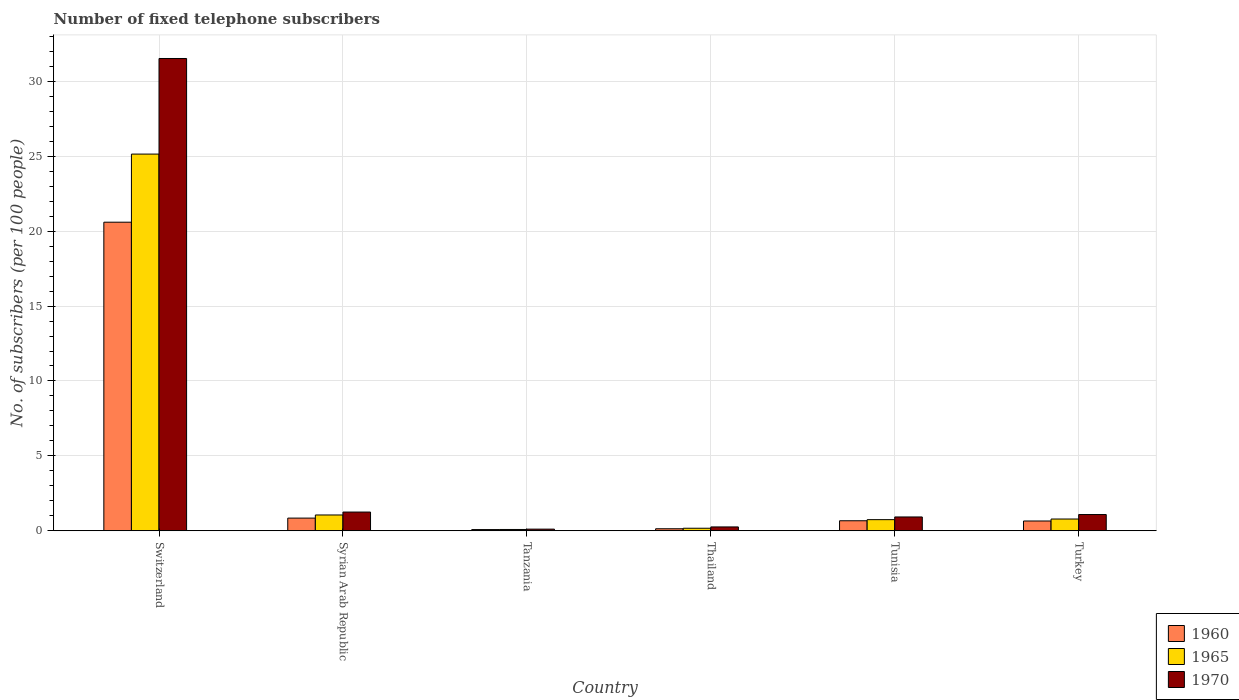How many different coloured bars are there?
Offer a terse response. 3. How many groups of bars are there?
Offer a terse response. 6. What is the label of the 5th group of bars from the left?
Give a very brief answer. Tunisia. What is the number of fixed telephone subscribers in 1970 in Turkey?
Give a very brief answer. 1.08. Across all countries, what is the maximum number of fixed telephone subscribers in 1970?
Give a very brief answer. 31.53. Across all countries, what is the minimum number of fixed telephone subscribers in 1965?
Provide a succinct answer. 0.09. In which country was the number of fixed telephone subscribers in 1965 maximum?
Make the answer very short. Switzerland. In which country was the number of fixed telephone subscribers in 1970 minimum?
Provide a succinct answer. Tanzania. What is the total number of fixed telephone subscribers in 1960 in the graph?
Your response must be concise. 22.99. What is the difference between the number of fixed telephone subscribers in 1960 in Tanzania and that in Turkey?
Your answer should be compact. -0.57. What is the difference between the number of fixed telephone subscribers in 1965 in Tunisia and the number of fixed telephone subscribers in 1960 in Tanzania?
Keep it short and to the point. 0.66. What is the average number of fixed telephone subscribers in 1965 per country?
Your response must be concise. 4.66. What is the difference between the number of fixed telephone subscribers of/in 1960 and number of fixed telephone subscribers of/in 1965 in Tanzania?
Give a very brief answer. -0.01. In how many countries, is the number of fixed telephone subscribers in 1965 greater than 25?
Provide a short and direct response. 1. What is the ratio of the number of fixed telephone subscribers in 1970 in Syrian Arab Republic to that in Tanzania?
Ensure brevity in your answer.  11.36. Is the difference between the number of fixed telephone subscribers in 1960 in Syrian Arab Republic and Tunisia greater than the difference between the number of fixed telephone subscribers in 1965 in Syrian Arab Republic and Tunisia?
Provide a short and direct response. No. What is the difference between the highest and the second highest number of fixed telephone subscribers in 1965?
Offer a terse response. -24.36. What is the difference between the highest and the lowest number of fixed telephone subscribers in 1965?
Provide a succinct answer. 25.06. What does the 2nd bar from the left in Tunisia represents?
Your answer should be compact. 1965. What does the 2nd bar from the right in Tunisia represents?
Give a very brief answer. 1965. Are all the bars in the graph horizontal?
Your response must be concise. No. What is the difference between two consecutive major ticks on the Y-axis?
Offer a terse response. 5. Are the values on the major ticks of Y-axis written in scientific E-notation?
Your answer should be very brief. No. Where does the legend appear in the graph?
Ensure brevity in your answer.  Bottom right. How many legend labels are there?
Give a very brief answer. 3. How are the legend labels stacked?
Give a very brief answer. Vertical. What is the title of the graph?
Give a very brief answer. Number of fixed telephone subscribers. Does "2002" appear as one of the legend labels in the graph?
Your answer should be compact. No. What is the label or title of the X-axis?
Ensure brevity in your answer.  Country. What is the label or title of the Y-axis?
Your answer should be compact. No. of subscribers (per 100 people). What is the No. of subscribers (per 100 people) in 1960 in Switzerland?
Give a very brief answer. 20.6. What is the No. of subscribers (per 100 people) of 1965 in Switzerland?
Your answer should be compact. 25.15. What is the No. of subscribers (per 100 people) of 1970 in Switzerland?
Provide a short and direct response. 31.53. What is the No. of subscribers (per 100 people) in 1960 in Syrian Arab Republic?
Your answer should be very brief. 0.85. What is the No. of subscribers (per 100 people) of 1965 in Syrian Arab Republic?
Offer a very short reply. 1.06. What is the No. of subscribers (per 100 people) of 1970 in Syrian Arab Republic?
Your answer should be very brief. 1.25. What is the No. of subscribers (per 100 people) of 1960 in Tanzania?
Your answer should be very brief. 0.08. What is the No. of subscribers (per 100 people) of 1965 in Tanzania?
Ensure brevity in your answer.  0.09. What is the No. of subscribers (per 100 people) in 1970 in Tanzania?
Provide a short and direct response. 0.11. What is the No. of subscribers (per 100 people) of 1960 in Thailand?
Provide a succinct answer. 0.14. What is the No. of subscribers (per 100 people) of 1965 in Thailand?
Provide a succinct answer. 0.17. What is the No. of subscribers (per 100 people) of 1970 in Thailand?
Ensure brevity in your answer.  0.26. What is the No. of subscribers (per 100 people) in 1960 in Tunisia?
Your answer should be very brief. 0.67. What is the No. of subscribers (per 100 people) of 1965 in Tunisia?
Keep it short and to the point. 0.74. What is the No. of subscribers (per 100 people) of 1970 in Tunisia?
Keep it short and to the point. 0.92. What is the No. of subscribers (per 100 people) in 1960 in Turkey?
Provide a succinct answer. 0.65. What is the No. of subscribers (per 100 people) in 1965 in Turkey?
Offer a very short reply. 0.79. What is the No. of subscribers (per 100 people) in 1970 in Turkey?
Your answer should be compact. 1.08. Across all countries, what is the maximum No. of subscribers (per 100 people) of 1960?
Provide a succinct answer. 20.6. Across all countries, what is the maximum No. of subscribers (per 100 people) in 1965?
Give a very brief answer. 25.15. Across all countries, what is the maximum No. of subscribers (per 100 people) of 1970?
Keep it short and to the point. 31.53. Across all countries, what is the minimum No. of subscribers (per 100 people) in 1960?
Make the answer very short. 0.08. Across all countries, what is the minimum No. of subscribers (per 100 people) in 1965?
Your answer should be compact. 0.09. Across all countries, what is the minimum No. of subscribers (per 100 people) of 1970?
Ensure brevity in your answer.  0.11. What is the total No. of subscribers (per 100 people) of 1960 in the graph?
Offer a very short reply. 22.99. What is the total No. of subscribers (per 100 people) of 1965 in the graph?
Ensure brevity in your answer.  27.99. What is the total No. of subscribers (per 100 people) of 1970 in the graph?
Your answer should be compact. 35.15. What is the difference between the No. of subscribers (per 100 people) in 1960 in Switzerland and that in Syrian Arab Republic?
Make the answer very short. 19.75. What is the difference between the No. of subscribers (per 100 people) in 1965 in Switzerland and that in Syrian Arab Republic?
Your response must be concise. 24.09. What is the difference between the No. of subscribers (per 100 people) of 1970 in Switzerland and that in Syrian Arab Republic?
Provide a succinct answer. 30.28. What is the difference between the No. of subscribers (per 100 people) in 1960 in Switzerland and that in Tanzania?
Ensure brevity in your answer.  20.52. What is the difference between the No. of subscribers (per 100 people) in 1965 in Switzerland and that in Tanzania?
Offer a terse response. 25.06. What is the difference between the No. of subscribers (per 100 people) of 1970 in Switzerland and that in Tanzania?
Your response must be concise. 31.42. What is the difference between the No. of subscribers (per 100 people) of 1960 in Switzerland and that in Thailand?
Keep it short and to the point. 20.46. What is the difference between the No. of subscribers (per 100 people) in 1965 in Switzerland and that in Thailand?
Make the answer very short. 24.98. What is the difference between the No. of subscribers (per 100 people) of 1970 in Switzerland and that in Thailand?
Make the answer very short. 31.27. What is the difference between the No. of subscribers (per 100 people) of 1960 in Switzerland and that in Tunisia?
Keep it short and to the point. 19.93. What is the difference between the No. of subscribers (per 100 people) in 1965 in Switzerland and that in Tunisia?
Keep it short and to the point. 24.4. What is the difference between the No. of subscribers (per 100 people) of 1970 in Switzerland and that in Tunisia?
Offer a very short reply. 30.6. What is the difference between the No. of subscribers (per 100 people) in 1960 in Switzerland and that in Turkey?
Ensure brevity in your answer.  19.95. What is the difference between the No. of subscribers (per 100 people) of 1965 in Switzerland and that in Turkey?
Ensure brevity in your answer.  24.36. What is the difference between the No. of subscribers (per 100 people) in 1970 in Switzerland and that in Turkey?
Your response must be concise. 30.44. What is the difference between the No. of subscribers (per 100 people) of 1960 in Syrian Arab Republic and that in Tanzania?
Provide a short and direct response. 0.77. What is the difference between the No. of subscribers (per 100 people) of 1965 in Syrian Arab Republic and that in Tanzania?
Provide a succinct answer. 0.97. What is the difference between the No. of subscribers (per 100 people) of 1970 in Syrian Arab Republic and that in Tanzania?
Make the answer very short. 1.14. What is the difference between the No. of subscribers (per 100 people) in 1960 in Syrian Arab Republic and that in Thailand?
Offer a terse response. 0.71. What is the difference between the No. of subscribers (per 100 people) of 1965 in Syrian Arab Republic and that in Thailand?
Your answer should be compact. 0.89. What is the difference between the No. of subscribers (per 100 people) in 1960 in Syrian Arab Republic and that in Tunisia?
Provide a short and direct response. 0.18. What is the difference between the No. of subscribers (per 100 people) in 1965 in Syrian Arab Republic and that in Tunisia?
Provide a short and direct response. 0.31. What is the difference between the No. of subscribers (per 100 people) of 1970 in Syrian Arab Republic and that in Tunisia?
Your answer should be compact. 0.33. What is the difference between the No. of subscribers (per 100 people) in 1960 in Syrian Arab Republic and that in Turkey?
Provide a succinct answer. 0.19. What is the difference between the No. of subscribers (per 100 people) of 1965 in Syrian Arab Republic and that in Turkey?
Your answer should be compact. 0.27. What is the difference between the No. of subscribers (per 100 people) in 1960 in Tanzania and that in Thailand?
Offer a very short reply. -0.06. What is the difference between the No. of subscribers (per 100 people) of 1965 in Tanzania and that in Thailand?
Provide a short and direct response. -0.08. What is the difference between the No. of subscribers (per 100 people) in 1970 in Tanzania and that in Thailand?
Provide a succinct answer. -0.15. What is the difference between the No. of subscribers (per 100 people) of 1960 in Tanzania and that in Tunisia?
Your answer should be compact. -0.59. What is the difference between the No. of subscribers (per 100 people) of 1965 in Tanzania and that in Tunisia?
Keep it short and to the point. -0.66. What is the difference between the No. of subscribers (per 100 people) of 1970 in Tanzania and that in Tunisia?
Your answer should be very brief. -0.81. What is the difference between the No. of subscribers (per 100 people) in 1960 in Tanzania and that in Turkey?
Make the answer very short. -0.57. What is the difference between the No. of subscribers (per 100 people) of 1965 in Tanzania and that in Turkey?
Keep it short and to the point. -0.7. What is the difference between the No. of subscribers (per 100 people) of 1970 in Tanzania and that in Turkey?
Your answer should be compact. -0.97. What is the difference between the No. of subscribers (per 100 people) of 1960 in Thailand and that in Tunisia?
Your response must be concise. -0.53. What is the difference between the No. of subscribers (per 100 people) in 1965 in Thailand and that in Tunisia?
Give a very brief answer. -0.57. What is the difference between the No. of subscribers (per 100 people) of 1970 in Thailand and that in Tunisia?
Your answer should be compact. -0.67. What is the difference between the No. of subscribers (per 100 people) in 1960 in Thailand and that in Turkey?
Offer a terse response. -0.52. What is the difference between the No. of subscribers (per 100 people) in 1965 in Thailand and that in Turkey?
Your response must be concise. -0.62. What is the difference between the No. of subscribers (per 100 people) of 1970 in Thailand and that in Turkey?
Keep it short and to the point. -0.83. What is the difference between the No. of subscribers (per 100 people) of 1960 in Tunisia and that in Turkey?
Ensure brevity in your answer.  0.02. What is the difference between the No. of subscribers (per 100 people) of 1965 in Tunisia and that in Turkey?
Offer a terse response. -0.04. What is the difference between the No. of subscribers (per 100 people) of 1970 in Tunisia and that in Turkey?
Offer a very short reply. -0.16. What is the difference between the No. of subscribers (per 100 people) of 1960 in Switzerland and the No. of subscribers (per 100 people) of 1965 in Syrian Arab Republic?
Provide a succinct answer. 19.54. What is the difference between the No. of subscribers (per 100 people) of 1960 in Switzerland and the No. of subscribers (per 100 people) of 1970 in Syrian Arab Republic?
Ensure brevity in your answer.  19.35. What is the difference between the No. of subscribers (per 100 people) of 1965 in Switzerland and the No. of subscribers (per 100 people) of 1970 in Syrian Arab Republic?
Provide a succinct answer. 23.9. What is the difference between the No. of subscribers (per 100 people) of 1960 in Switzerland and the No. of subscribers (per 100 people) of 1965 in Tanzania?
Provide a succinct answer. 20.51. What is the difference between the No. of subscribers (per 100 people) of 1960 in Switzerland and the No. of subscribers (per 100 people) of 1970 in Tanzania?
Provide a short and direct response. 20.49. What is the difference between the No. of subscribers (per 100 people) of 1965 in Switzerland and the No. of subscribers (per 100 people) of 1970 in Tanzania?
Offer a terse response. 25.04. What is the difference between the No. of subscribers (per 100 people) of 1960 in Switzerland and the No. of subscribers (per 100 people) of 1965 in Thailand?
Your answer should be very brief. 20.43. What is the difference between the No. of subscribers (per 100 people) in 1960 in Switzerland and the No. of subscribers (per 100 people) in 1970 in Thailand?
Offer a terse response. 20.34. What is the difference between the No. of subscribers (per 100 people) in 1965 in Switzerland and the No. of subscribers (per 100 people) in 1970 in Thailand?
Your answer should be very brief. 24.89. What is the difference between the No. of subscribers (per 100 people) in 1960 in Switzerland and the No. of subscribers (per 100 people) in 1965 in Tunisia?
Ensure brevity in your answer.  19.86. What is the difference between the No. of subscribers (per 100 people) of 1960 in Switzerland and the No. of subscribers (per 100 people) of 1970 in Tunisia?
Your answer should be compact. 19.68. What is the difference between the No. of subscribers (per 100 people) of 1965 in Switzerland and the No. of subscribers (per 100 people) of 1970 in Tunisia?
Provide a short and direct response. 24.22. What is the difference between the No. of subscribers (per 100 people) of 1960 in Switzerland and the No. of subscribers (per 100 people) of 1965 in Turkey?
Offer a terse response. 19.81. What is the difference between the No. of subscribers (per 100 people) of 1960 in Switzerland and the No. of subscribers (per 100 people) of 1970 in Turkey?
Your response must be concise. 19.52. What is the difference between the No. of subscribers (per 100 people) in 1965 in Switzerland and the No. of subscribers (per 100 people) in 1970 in Turkey?
Offer a very short reply. 24.06. What is the difference between the No. of subscribers (per 100 people) of 1960 in Syrian Arab Republic and the No. of subscribers (per 100 people) of 1965 in Tanzania?
Offer a terse response. 0.76. What is the difference between the No. of subscribers (per 100 people) of 1960 in Syrian Arab Republic and the No. of subscribers (per 100 people) of 1970 in Tanzania?
Keep it short and to the point. 0.74. What is the difference between the No. of subscribers (per 100 people) of 1965 in Syrian Arab Republic and the No. of subscribers (per 100 people) of 1970 in Tanzania?
Your response must be concise. 0.95. What is the difference between the No. of subscribers (per 100 people) of 1960 in Syrian Arab Republic and the No. of subscribers (per 100 people) of 1965 in Thailand?
Provide a short and direct response. 0.68. What is the difference between the No. of subscribers (per 100 people) in 1960 in Syrian Arab Republic and the No. of subscribers (per 100 people) in 1970 in Thailand?
Give a very brief answer. 0.59. What is the difference between the No. of subscribers (per 100 people) in 1965 in Syrian Arab Republic and the No. of subscribers (per 100 people) in 1970 in Thailand?
Keep it short and to the point. 0.8. What is the difference between the No. of subscribers (per 100 people) of 1960 in Syrian Arab Republic and the No. of subscribers (per 100 people) of 1965 in Tunisia?
Offer a terse response. 0.1. What is the difference between the No. of subscribers (per 100 people) of 1960 in Syrian Arab Republic and the No. of subscribers (per 100 people) of 1970 in Tunisia?
Your answer should be very brief. -0.08. What is the difference between the No. of subscribers (per 100 people) in 1965 in Syrian Arab Republic and the No. of subscribers (per 100 people) in 1970 in Tunisia?
Your answer should be very brief. 0.13. What is the difference between the No. of subscribers (per 100 people) of 1960 in Syrian Arab Republic and the No. of subscribers (per 100 people) of 1965 in Turkey?
Offer a terse response. 0.06. What is the difference between the No. of subscribers (per 100 people) in 1960 in Syrian Arab Republic and the No. of subscribers (per 100 people) in 1970 in Turkey?
Give a very brief answer. -0.24. What is the difference between the No. of subscribers (per 100 people) in 1965 in Syrian Arab Republic and the No. of subscribers (per 100 people) in 1970 in Turkey?
Provide a succinct answer. -0.03. What is the difference between the No. of subscribers (per 100 people) in 1960 in Tanzania and the No. of subscribers (per 100 people) in 1965 in Thailand?
Make the answer very short. -0.09. What is the difference between the No. of subscribers (per 100 people) of 1960 in Tanzania and the No. of subscribers (per 100 people) of 1970 in Thailand?
Make the answer very short. -0.18. What is the difference between the No. of subscribers (per 100 people) in 1965 in Tanzania and the No. of subscribers (per 100 people) in 1970 in Thailand?
Your answer should be compact. -0.17. What is the difference between the No. of subscribers (per 100 people) in 1960 in Tanzania and the No. of subscribers (per 100 people) in 1965 in Tunisia?
Offer a terse response. -0.66. What is the difference between the No. of subscribers (per 100 people) of 1960 in Tanzania and the No. of subscribers (per 100 people) of 1970 in Tunisia?
Your answer should be very brief. -0.84. What is the difference between the No. of subscribers (per 100 people) in 1965 in Tanzania and the No. of subscribers (per 100 people) in 1970 in Tunisia?
Provide a short and direct response. -0.84. What is the difference between the No. of subscribers (per 100 people) in 1960 in Tanzania and the No. of subscribers (per 100 people) in 1965 in Turkey?
Ensure brevity in your answer.  -0.7. What is the difference between the No. of subscribers (per 100 people) in 1960 in Tanzania and the No. of subscribers (per 100 people) in 1970 in Turkey?
Your response must be concise. -1. What is the difference between the No. of subscribers (per 100 people) of 1965 in Tanzania and the No. of subscribers (per 100 people) of 1970 in Turkey?
Make the answer very short. -1. What is the difference between the No. of subscribers (per 100 people) of 1960 in Thailand and the No. of subscribers (per 100 people) of 1965 in Tunisia?
Offer a very short reply. -0.61. What is the difference between the No. of subscribers (per 100 people) of 1960 in Thailand and the No. of subscribers (per 100 people) of 1970 in Tunisia?
Give a very brief answer. -0.79. What is the difference between the No. of subscribers (per 100 people) of 1965 in Thailand and the No. of subscribers (per 100 people) of 1970 in Tunisia?
Offer a very short reply. -0.75. What is the difference between the No. of subscribers (per 100 people) of 1960 in Thailand and the No. of subscribers (per 100 people) of 1965 in Turkey?
Provide a short and direct response. -0.65. What is the difference between the No. of subscribers (per 100 people) of 1960 in Thailand and the No. of subscribers (per 100 people) of 1970 in Turkey?
Make the answer very short. -0.95. What is the difference between the No. of subscribers (per 100 people) in 1965 in Thailand and the No. of subscribers (per 100 people) in 1970 in Turkey?
Your answer should be compact. -0.91. What is the difference between the No. of subscribers (per 100 people) in 1960 in Tunisia and the No. of subscribers (per 100 people) in 1965 in Turkey?
Keep it short and to the point. -0.12. What is the difference between the No. of subscribers (per 100 people) of 1960 in Tunisia and the No. of subscribers (per 100 people) of 1970 in Turkey?
Make the answer very short. -0.41. What is the difference between the No. of subscribers (per 100 people) of 1965 in Tunisia and the No. of subscribers (per 100 people) of 1970 in Turkey?
Your answer should be compact. -0.34. What is the average No. of subscribers (per 100 people) in 1960 per country?
Give a very brief answer. 3.83. What is the average No. of subscribers (per 100 people) of 1965 per country?
Provide a short and direct response. 4.66. What is the average No. of subscribers (per 100 people) of 1970 per country?
Ensure brevity in your answer.  5.86. What is the difference between the No. of subscribers (per 100 people) in 1960 and No. of subscribers (per 100 people) in 1965 in Switzerland?
Your response must be concise. -4.55. What is the difference between the No. of subscribers (per 100 people) of 1960 and No. of subscribers (per 100 people) of 1970 in Switzerland?
Your response must be concise. -10.93. What is the difference between the No. of subscribers (per 100 people) of 1965 and No. of subscribers (per 100 people) of 1970 in Switzerland?
Offer a terse response. -6.38. What is the difference between the No. of subscribers (per 100 people) of 1960 and No. of subscribers (per 100 people) of 1965 in Syrian Arab Republic?
Provide a short and direct response. -0.21. What is the difference between the No. of subscribers (per 100 people) in 1960 and No. of subscribers (per 100 people) in 1970 in Syrian Arab Republic?
Provide a short and direct response. -0.4. What is the difference between the No. of subscribers (per 100 people) in 1965 and No. of subscribers (per 100 people) in 1970 in Syrian Arab Republic?
Your answer should be compact. -0.2. What is the difference between the No. of subscribers (per 100 people) in 1960 and No. of subscribers (per 100 people) in 1965 in Tanzania?
Give a very brief answer. -0.01. What is the difference between the No. of subscribers (per 100 people) in 1960 and No. of subscribers (per 100 people) in 1970 in Tanzania?
Offer a very short reply. -0.03. What is the difference between the No. of subscribers (per 100 people) of 1965 and No. of subscribers (per 100 people) of 1970 in Tanzania?
Offer a terse response. -0.02. What is the difference between the No. of subscribers (per 100 people) of 1960 and No. of subscribers (per 100 people) of 1965 in Thailand?
Make the answer very short. -0.03. What is the difference between the No. of subscribers (per 100 people) in 1960 and No. of subscribers (per 100 people) in 1970 in Thailand?
Offer a very short reply. -0.12. What is the difference between the No. of subscribers (per 100 people) in 1965 and No. of subscribers (per 100 people) in 1970 in Thailand?
Provide a succinct answer. -0.09. What is the difference between the No. of subscribers (per 100 people) of 1960 and No. of subscribers (per 100 people) of 1965 in Tunisia?
Ensure brevity in your answer.  -0.07. What is the difference between the No. of subscribers (per 100 people) in 1960 and No. of subscribers (per 100 people) in 1970 in Tunisia?
Offer a terse response. -0.25. What is the difference between the No. of subscribers (per 100 people) of 1965 and No. of subscribers (per 100 people) of 1970 in Tunisia?
Your answer should be very brief. -0.18. What is the difference between the No. of subscribers (per 100 people) of 1960 and No. of subscribers (per 100 people) of 1965 in Turkey?
Provide a short and direct response. -0.13. What is the difference between the No. of subscribers (per 100 people) in 1960 and No. of subscribers (per 100 people) in 1970 in Turkey?
Your response must be concise. -0.43. What is the difference between the No. of subscribers (per 100 people) of 1965 and No. of subscribers (per 100 people) of 1970 in Turkey?
Offer a terse response. -0.3. What is the ratio of the No. of subscribers (per 100 people) in 1960 in Switzerland to that in Syrian Arab Republic?
Provide a short and direct response. 24.33. What is the ratio of the No. of subscribers (per 100 people) in 1965 in Switzerland to that in Syrian Arab Republic?
Your response must be concise. 23.82. What is the ratio of the No. of subscribers (per 100 people) in 1970 in Switzerland to that in Syrian Arab Republic?
Your response must be concise. 25.2. What is the ratio of the No. of subscribers (per 100 people) of 1960 in Switzerland to that in Tanzania?
Ensure brevity in your answer.  255.26. What is the ratio of the No. of subscribers (per 100 people) in 1965 in Switzerland to that in Tanzania?
Provide a short and direct response. 287.14. What is the ratio of the No. of subscribers (per 100 people) of 1970 in Switzerland to that in Tanzania?
Ensure brevity in your answer.  286.38. What is the ratio of the No. of subscribers (per 100 people) of 1960 in Switzerland to that in Thailand?
Offer a terse response. 151.73. What is the ratio of the No. of subscribers (per 100 people) of 1965 in Switzerland to that in Thailand?
Ensure brevity in your answer.  148.16. What is the ratio of the No. of subscribers (per 100 people) in 1970 in Switzerland to that in Thailand?
Offer a terse response. 122.39. What is the ratio of the No. of subscribers (per 100 people) of 1960 in Switzerland to that in Tunisia?
Keep it short and to the point. 30.76. What is the ratio of the No. of subscribers (per 100 people) in 1965 in Switzerland to that in Tunisia?
Offer a terse response. 33.82. What is the ratio of the No. of subscribers (per 100 people) in 1970 in Switzerland to that in Tunisia?
Your answer should be compact. 34.15. What is the ratio of the No. of subscribers (per 100 people) of 1960 in Switzerland to that in Turkey?
Offer a terse response. 31.53. What is the ratio of the No. of subscribers (per 100 people) in 1965 in Switzerland to that in Turkey?
Your response must be concise. 32.03. What is the ratio of the No. of subscribers (per 100 people) in 1970 in Switzerland to that in Turkey?
Give a very brief answer. 29.08. What is the ratio of the No. of subscribers (per 100 people) in 1960 in Syrian Arab Republic to that in Tanzania?
Give a very brief answer. 10.49. What is the ratio of the No. of subscribers (per 100 people) in 1965 in Syrian Arab Republic to that in Tanzania?
Your answer should be compact. 12.06. What is the ratio of the No. of subscribers (per 100 people) of 1970 in Syrian Arab Republic to that in Tanzania?
Your answer should be very brief. 11.36. What is the ratio of the No. of subscribers (per 100 people) of 1960 in Syrian Arab Republic to that in Thailand?
Give a very brief answer. 6.24. What is the ratio of the No. of subscribers (per 100 people) of 1965 in Syrian Arab Republic to that in Thailand?
Your response must be concise. 6.22. What is the ratio of the No. of subscribers (per 100 people) of 1970 in Syrian Arab Republic to that in Thailand?
Offer a very short reply. 4.86. What is the ratio of the No. of subscribers (per 100 people) in 1960 in Syrian Arab Republic to that in Tunisia?
Your answer should be very brief. 1.26. What is the ratio of the No. of subscribers (per 100 people) in 1965 in Syrian Arab Republic to that in Tunisia?
Keep it short and to the point. 1.42. What is the ratio of the No. of subscribers (per 100 people) of 1970 in Syrian Arab Republic to that in Tunisia?
Give a very brief answer. 1.35. What is the ratio of the No. of subscribers (per 100 people) of 1960 in Syrian Arab Republic to that in Turkey?
Make the answer very short. 1.3. What is the ratio of the No. of subscribers (per 100 people) of 1965 in Syrian Arab Republic to that in Turkey?
Provide a succinct answer. 1.34. What is the ratio of the No. of subscribers (per 100 people) in 1970 in Syrian Arab Republic to that in Turkey?
Give a very brief answer. 1.15. What is the ratio of the No. of subscribers (per 100 people) of 1960 in Tanzania to that in Thailand?
Offer a very short reply. 0.59. What is the ratio of the No. of subscribers (per 100 people) in 1965 in Tanzania to that in Thailand?
Offer a very short reply. 0.52. What is the ratio of the No. of subscribers (per 100 people) in 1970 in Tanzania to that in Thailand?
Your response must be concise. 0.43. What is the ratio of the No. of subscribers (per 100 people) in 1960 in Tanzania to that in Tunisia?
Your answer should be compact. 0.12. What is the ratio of the No. of subscribers (per 100 people) of 1965 in Tanzania to that in Tunisia?
Provide a short and direct response. 0.12. What is the ratio of the No. of subscribers (per 100 people) in 1970 in Tanzania to that in Tunisia?
Offer a terse response. 0.12. What is the ratio of the No. of subscribers (per 100 people) in 1960 in Tanzania to that in Turkey?
Your answer should be compact. 0.12. What is the ratio of the No. of subscribers (per 100 people) in 1965 in Tanzania to that in Turkey?
Ensure brevity in your answer.  0.11. What is the ratio of the No. of subscribers (per 100 people) in 1970 in Tanzania to that in Turkey?
Provide a succinct answer. 0.1. What is the ratio of the No. of subscribers (per 100 people) in 1960 in Thailand to that in Tunisia?
Ensure brevity in your answer.  0.2. What is the ratio of the No. of subscribers (per 100 people) of 1965 in Thailand to that in Tunisia?
Offer a terse response. 0.23. What is the ratio of the No. of subscribers (per 100 people) in 1970 in Thailand to that in Tunisia?
Keep it short and to the point. 0.28. What is the ratio of the No. of subscribers (per 100 people) of 1960 in Thailand to that in Turkey?
Provide a short and direct response. 0.21. What is the ratio of the No. of subscribers (per 100 people) of 1965 in Thailand to that in Turkey?
Keep it short and to the point. 0.22. What is the ratio of the No. of subscribers (per 100 people) in 1970 in Thailand to that in Turkey?
Your answer should be compact. 0.24. What is the ratio of the No. of subscribers (per 100 people) in 1960 in Tunisia to that in Turkey?
Provide a succinct answer. 1.02. What is the ratio of the No. of subscribers (per 100 people) of 1965 in Tunisia to that in Turkey?
Ensure brevity in your answer.  0.95. What is the ratio of the No. of subscribers (per 100 people) in 1970 in Tunisia to that in Turkey?
Your answer should be very brief. 0.85. What is the difference between the highest and the second highest No. of subscribers (per 100 people) in 1960?
Your answer should be very brief. 19.75. What is the difference between the highest and the second highest No. of subscribers (per 100 people) of 1965?
Offer a terse response. 24.09. What is the difference between the highest and the second highest No. of subscribers (per 100 people) in 1970?
Provide a short and direct response. 30.28. What is the difference between the highest and the lowest No. of subscribers (per 100 people) in 1960?
Your response must be concise. 20.52. What is the difference between the highest and the lowest No. of subscribers (per 100 people) of 1965?
Offer a very short reply. 25.06. What is the difference between the highest and the lowest No. of subscribers (per 100 people) in 1970?
Offer a very short reply. 31.42. 